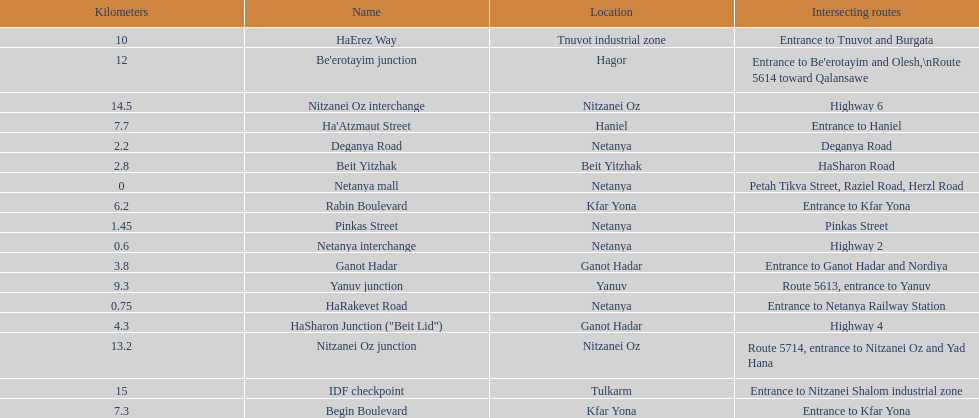Could you parse the entire table? {'header': ['Kilometers', 'Name', 'Location', 'Intersecting routes'], 'rows': [['10', 'HaErez Way', 'Tnuvot industrial zone', 'Entrance to Tnuvot and Burgata'], ['12', "Be'erotayim junction", 'Hagor', "Entrance to Be'erotayim and Olesh,\\nRoute 5614 toward Qalansawe"], ['14.5', 'Nitzanei Oz interchange', 'Nitzanei Oz', 'Highway 6'], ['7.7', "Ha'Atzmaut Street", 'Haniel', 'Entrance to Haniel'], ['2.2', 'Deganya Road', 'Netanya', 'Deganya Road'], ['2.8', 'Beit Yitzhak', 'Beit Yitzhak', 'HaSharon Road'], ['0', 'Netanya mall', 'Netanya', 'Petah Tikva Street, Raziel Road, Herzl Road'], ['6.2', 'Rabin Boulevard', 'Kfar Yona', 'Entrance to Kfar Yona'], ['1.45', 'Pinkas Street', 'Netanya', 'Pinkas Street'], ['0.6', 'Netanya interchange', 'Netanya', 'Highway 2'], ['3.8', 'Ganot Hadar', 'Ganot Hadar', 'Entrance to Ganot Hadar and Nordiya'], ['9.3', 'Yanuv junction', 'Yanuv', 'Route 5613, entrance to Yanuv'], ['0.75', 'HaRakevet Road', 'Netanya', 'Entrance to Netanya Railway Station'], ['4.3', 'HaSharon Junction ("Beit Lid")', 'Ganot Hadar', 'Highway 4'], ['13.2', 'Nitzanei Oz junction', 'Nitzanei Oz', 'Route 5714, entrance to Nitzanei Oz and Yad Hana'], ['15', 'IDF checkpoint', 'Tulkarm', 'Entrance to Nitzanei Shalom industrial zone'], ['7.3', 'Begin Boulevard', 'Kfar Yona', 'Entrance to Kfar Yona']]} Upon finishing deganya road, which section follows? Beit Yitzhak. 